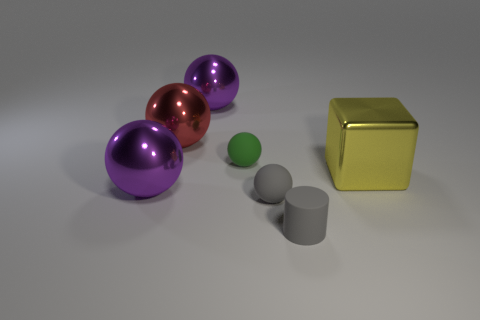Subtract all tiny green balls. How many balls are left? 4 Subtract all cylinders. How many objects are left? 6 Add 4 yellow shiny things. How many yellow shiny things are left? 5 Add 4 big green cylinders. How many big green cylinders exist? 4 Add 2 large blocks. How many objects exist? 9 Subtract all green spheres. How many spheres are left? 4 Subtract 0 brown balls. How many objects are left? 7 Subtract 4 balls. How many balls are left? 1 Subtract all cyan balls. Subtract all purple cylinders. How many balls are left? 5 Subtract all green blocks. How many cyan cylinders are left? 0 